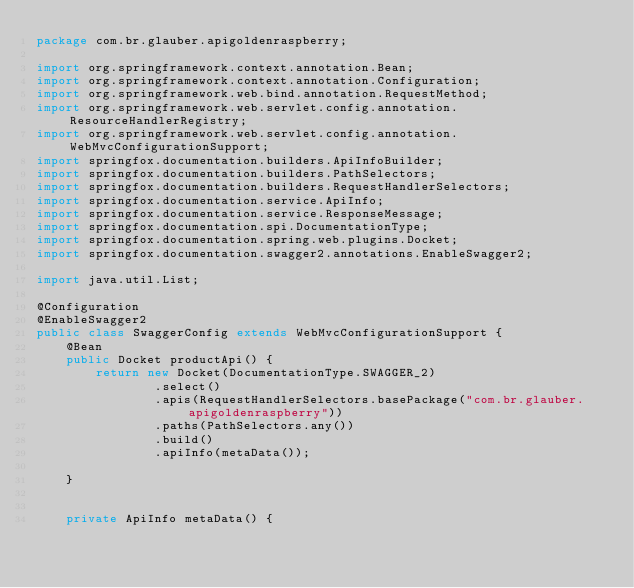Convert code to text. <code><loc_0><loc_0><loc_500><loc_500><_Java_>package com.br.glauber.apigoldenraspberry;

import org.springframework.context.annotation.Bean;
import org.springframework.context.annotation.Configuration;
import org.springframework.web.bind.annotation.RequestMethod;
import org.springframework.web.servlet.config.annotation.ResourceHandlerRegistry;
import org.springframework.web.servlet.config.annotation.WebMvcConfigurationSupport;
import springfox.documentation.builders.ApiInfoBuilder;
import springfox.documentation.builders.PathSelectors;
import springfox.documentation.builders.RequestHandlerSelectors;
import springfox.documentation.service.ApiInfo;
import springfox.documentation.service.ResponseMessage;
import springfox.documentation.spi.DocumentationType;
import springfox.documentation.spring.web.plugins.Docket;
import springfox.documentation.swagger2.annotations.EnableSwagger2;

import java.util.List;

@Configuration
@EnableSwagger2
public class SwaggerConfig extends WebMvcConfigurationSupport {
    @Bean
    public Docket productApi() {
        return new Docket(DocumentationType.SWAGGER_2)
                .select()
                .apis(RequestHandlerSelectors.basePackage("com.br.glauber.apigoldenraspberry"))
                .paths(PathSelectors.any())
                .build()
                .apiInfo(metaData());

    }


    private ApiInfo metaData() {</code> 